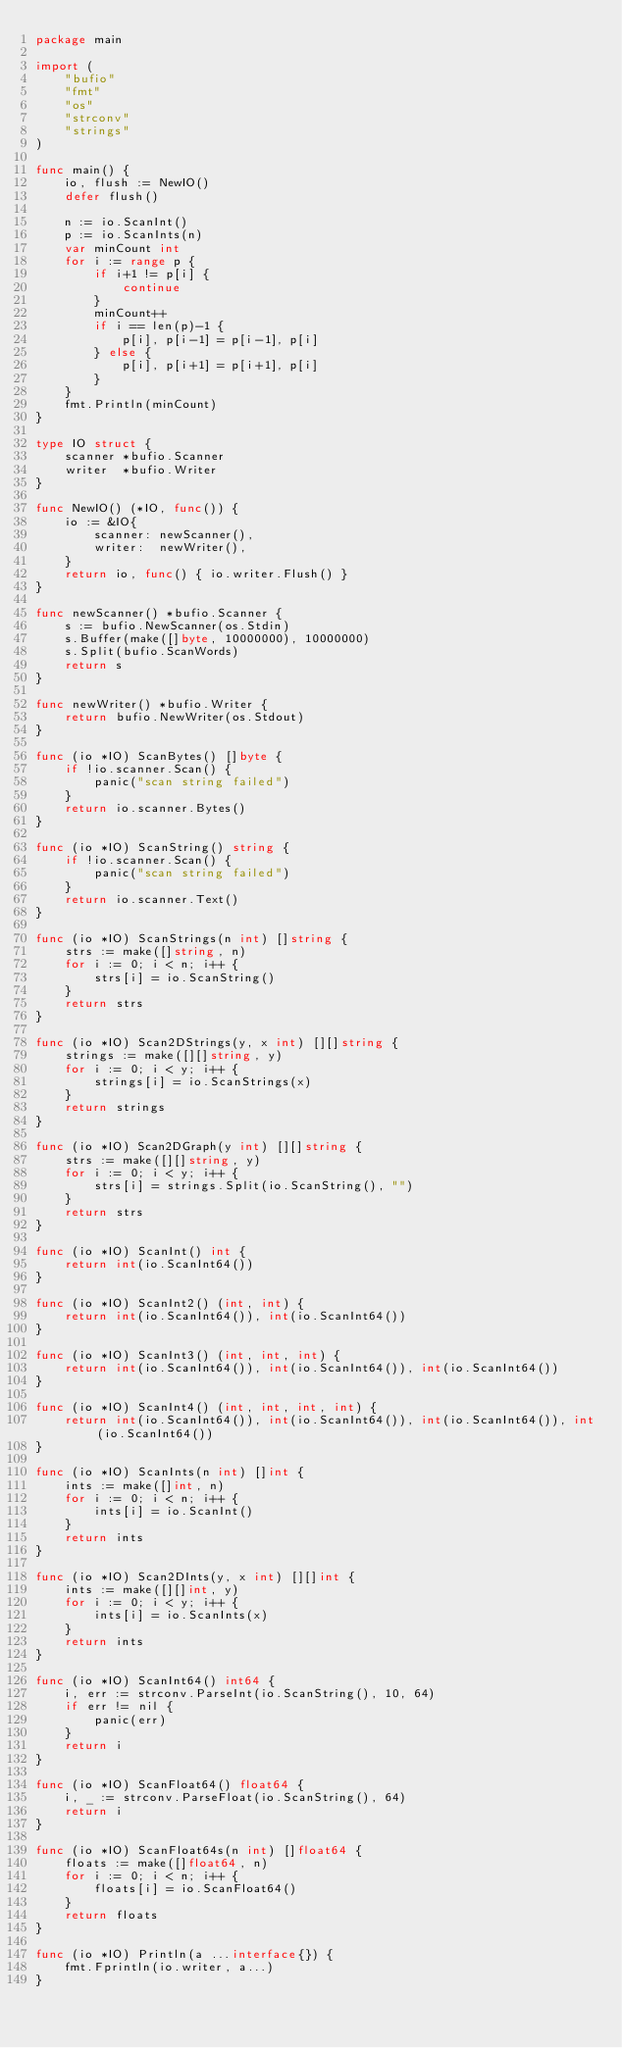Convert code to text. <code><loc_0><loc_0><loc_500><loc_500><_Go_>package main

import (
	"bufio"
	"fmt"
	"os"
	"strconv"
	"strings"
)

func main() {
	io, flush := NewIO()
	defer flush()

	n := io.ScanInt()
	p := io.ScanInts(n)
	var minCount int
	for i := range p {
		if i+1 != p[i] {
			continue
		}
		minCount++
		if i == len(p)-1 {
			p[i], p[i-1] = p[i-1], p[i]
		} else {
			p[i], p[i+1] = p[i+1], p[i]
		}
	}
	fmt.Println(minCount)
}

type IO struct {
	scanner *bufio.Scanner
	writer  *bufio.Writer
}

func NewIO() (*IO, func()) {
	io := &IO{
		scanner: newScanner(),
		writer:  newWriter(),
	}
	return io, func() { io.writer.Flush() }
}

func newScanner() *bufio.Scanner {
	s := bufio.NewScanner(os.Stdin)
	s.Buffer(make([]byte, 10000000), 10000000)
	s.Split(bufio.ScanWords)
	return s
}

func newWriter() *bufio.Writer {
	return bufio.NewWriter(os.Stdout)
}

func (io *IO) ScanBytes() []byte {
	if !io.scanner.Scan() {
		panic("scan string failed")
	}
	return io.scanner.Bytes()
}

func (io *IO) ScanString() string {
	if !io.scanner.Scan() {
		panic("scan string failed")
	}
	return io.scanner.Text()
}

func (io *IO) ScanStrings(n int) []string {
	strs := make([]string, n)
	for i := 0; i < n; i++ {
		strs[i] = io.ScanString()
	}
	return strs
}

func (io *IO) Scan2DStrings(y, x int) [][]string {
	strings := make([][]string, y)
	for i := 0; i < y; i++ {
		strings[i] = io.ScanStrings(x)
	}
	return strings
}

func (io *IO) Scan2DGraph(y int) [][]string {
	strs := make([][]string, y)
	for i := 0; i < y; i++ {
		strs[i] = strings.Split(io.ScanString(), "")
	}
	return strs
}

func (io *IO) ScanInt() int {
	return int(io.ScanInt64())
}

func (io *IO) ScanInt2() (int, int) {
	return int(io.ScanInt64()), int(io.ScanInt64())
}

func (io *IO) ScanInt3() (int, int, int) {
	return int(io.ScanInt64()), int(io.ScanInt64()), int(io.ScanInt64())
}

func (io *IO) ScanInt4() (int, int, int, int) {
	return int(io.ScanInt64()), int(io.ScanInt64()), int(io.ScanInt64()), int(io.ScanInt64())
}

func (io *IO) ScanInts(n int) []int {
	ints := make([]int, n)
	for i := 0; i < n; i++ {
		ints[i] = io.ScanInt()
	}
	return ints
}

func (io *IO) Scan2DInts(y, x int) [][]int {
	ints := make([][]int, y)
	for i := 0; i < y; i++ {
		ints[i] = io.ScanInts(x)
	}
	return ints
}

func (io *IO) ScanInt64() int64 {
	i, err := strconv.ParseInt(io.ScanString(), 10, 64)
	if err != nil {
		panic(err)
	}
	return i
}

func (io *IO) ScanFloat64() float64 {
	i, _ := strconv.ParseFloat(io.ScanString(), 64)
	return i
}

func (io *IO) ScanFloat64s(n int) []float64 {
	floats := make([]float64, n)
	for i := 0; i < n; i++ {
		floats[i] = io.ScanFloat64()
	}
	return floats
}

func (io *IO) Println(a ...interface{}) {
	fmt.Fprintln(io.writer, a...)
}
</code> 